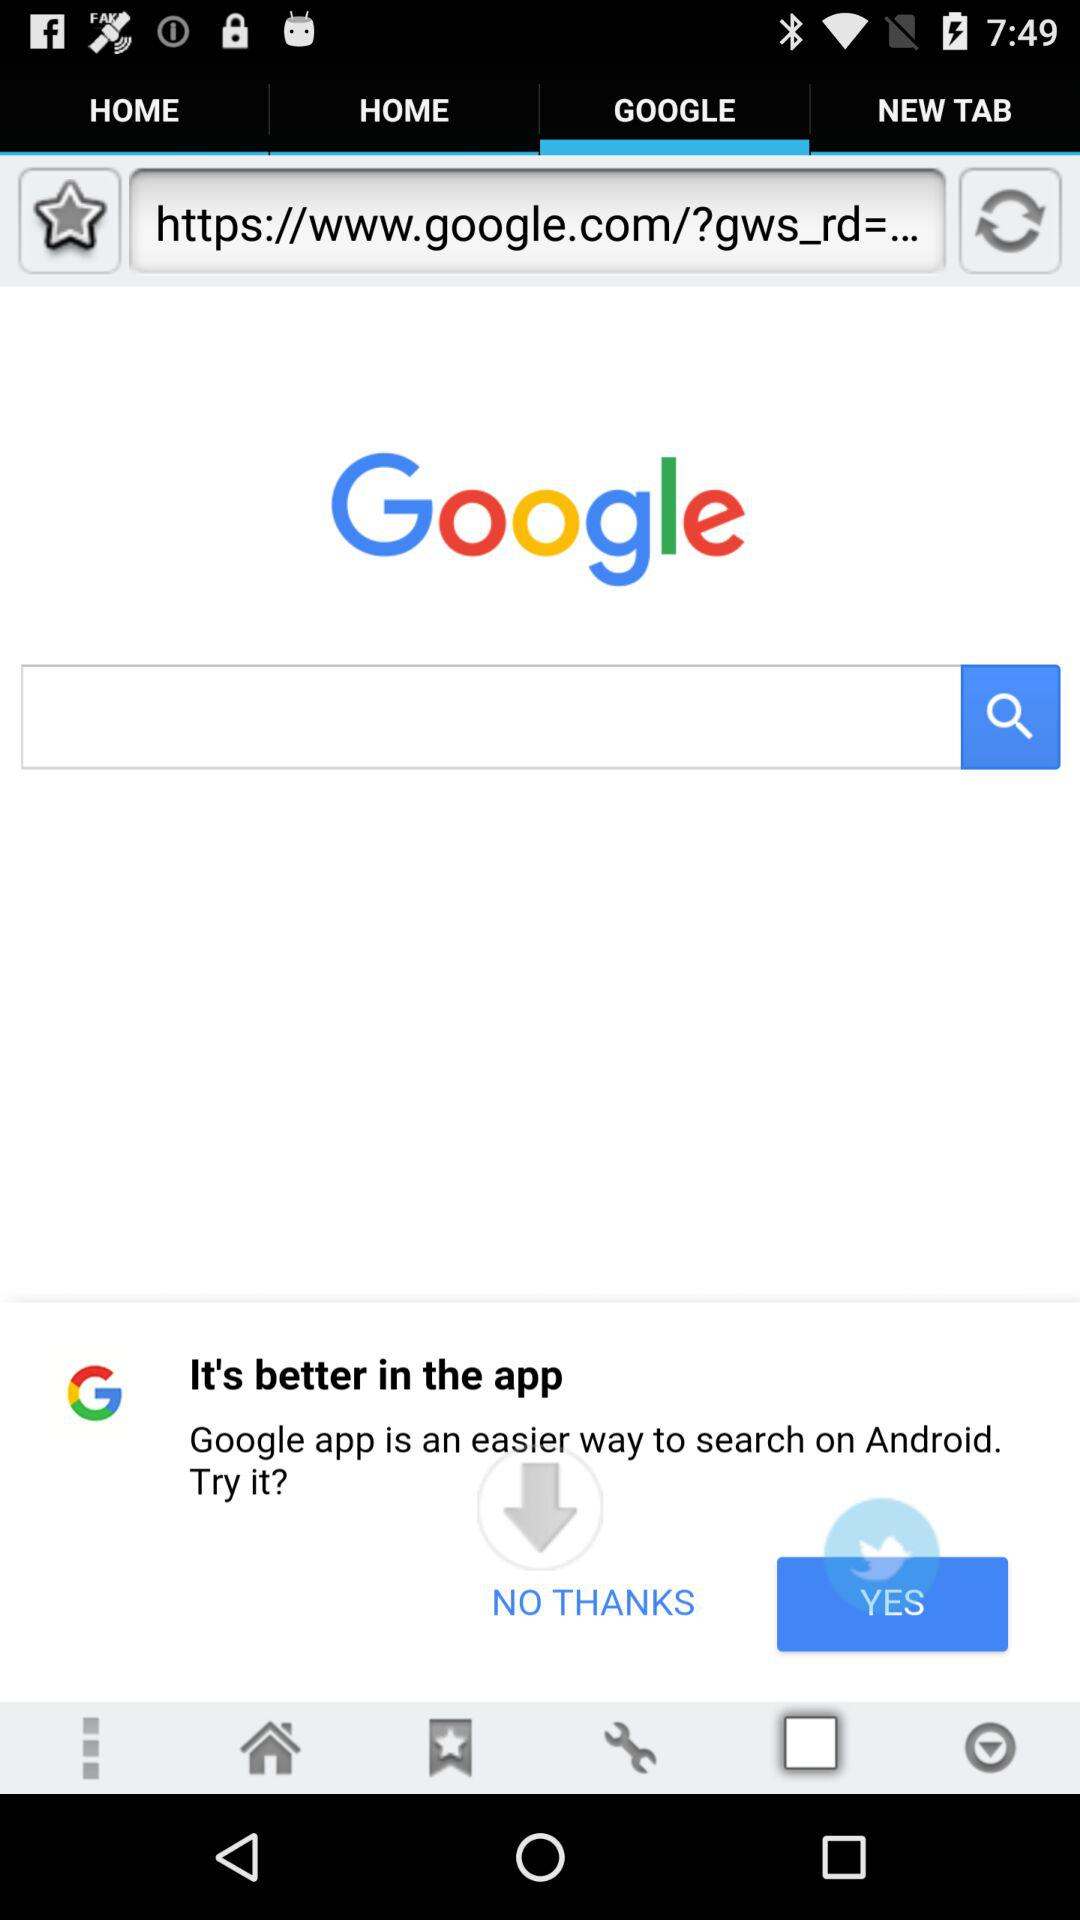Which tab is selected? The selected tab is "GOOGLE". 